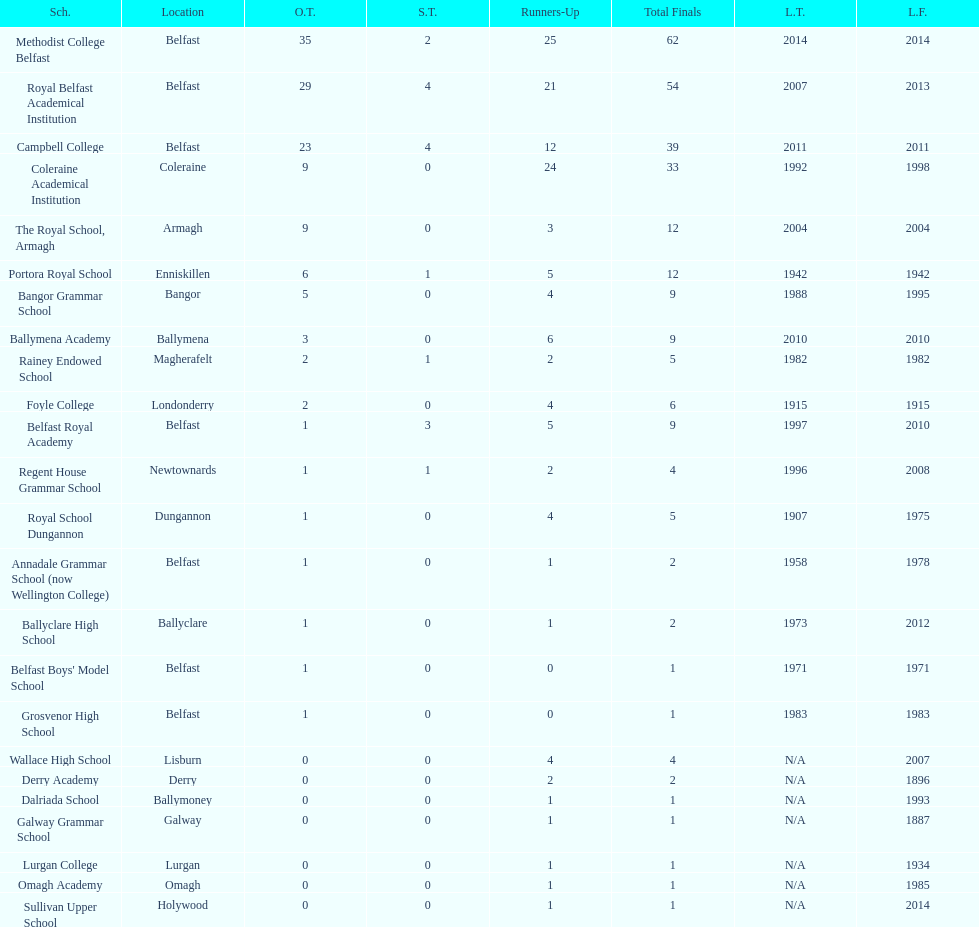How many schools have had at least 3 share titles? 3. 